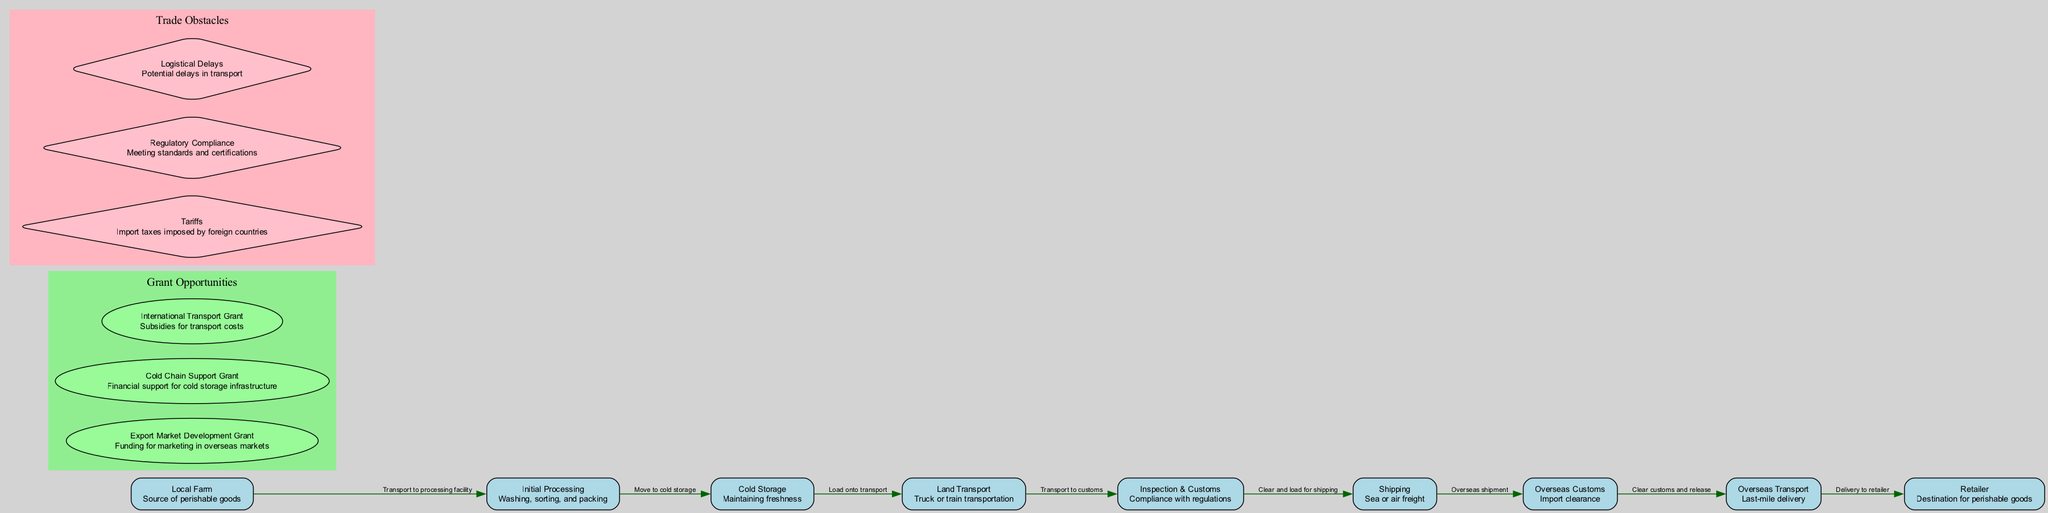What is the first node in the flow? The first node in the flow is labeled "Local Farm," which represents the source of perishable goods. The question directly pertains to identifying the starting point in the food chain diagram.
Answer: Local Farm How many grant opportunities are listed in the diagram? The diagram lists three grant opportunities: Export Market Development Grant, Cold Chain Support Grant, and International Transport Grant. Counting these grants gives the answer.
Answer: 3 What is the final destination node for the perishable goods? The final node in the flow is labeled "Retailer," indicating it serves as the destination for the perishable goods being transported through the chain.
Answer: Retailer Which node represents compliance with regulations? The node labeled "Inspection & Customs" represents compliance with regulations as it indicates the process of meeting necessary standards before goods are shipped.
Answer: Inspection & Customs What is the relationship between "Cold Storage" and "Land Transport"? The edge connecting "Cold Storage" to "Land Transport" describes the action of loading goods onto transport, indicating that goods need to be moved from cold storage to be transported.
Answer: Load onto transport What trade obstacle involves import taxes? The trade obstacle labeled "Tariffs" specifically describes import taxes that are imposed by foreign countries, which can affect trade.
Answer: Tariffs How is the "Initial Processing" node connected to "Cold Storage"? The connection between "Initial Processing" and "Cold Storage" is described by the edge labeled "Move to cold storage," indicating that after initial processing, goods are moved to maintain their freshness.
Answer: Move to cold storage What type of grant supports cold storage infrastructure? The grant labeled "Cold Chain Support Grant" is specifically focused on providing financial assistance for cold storage infrastructure.
Answer: Cold Chain Support Grant What is a potential complication during transport, as indicated in the diagram? The obstacle labeled "Logistical Delays" signifies potential complications that may occur during the transport process, affecting the timely delivery of goods.
Answer: Logistical Delays 